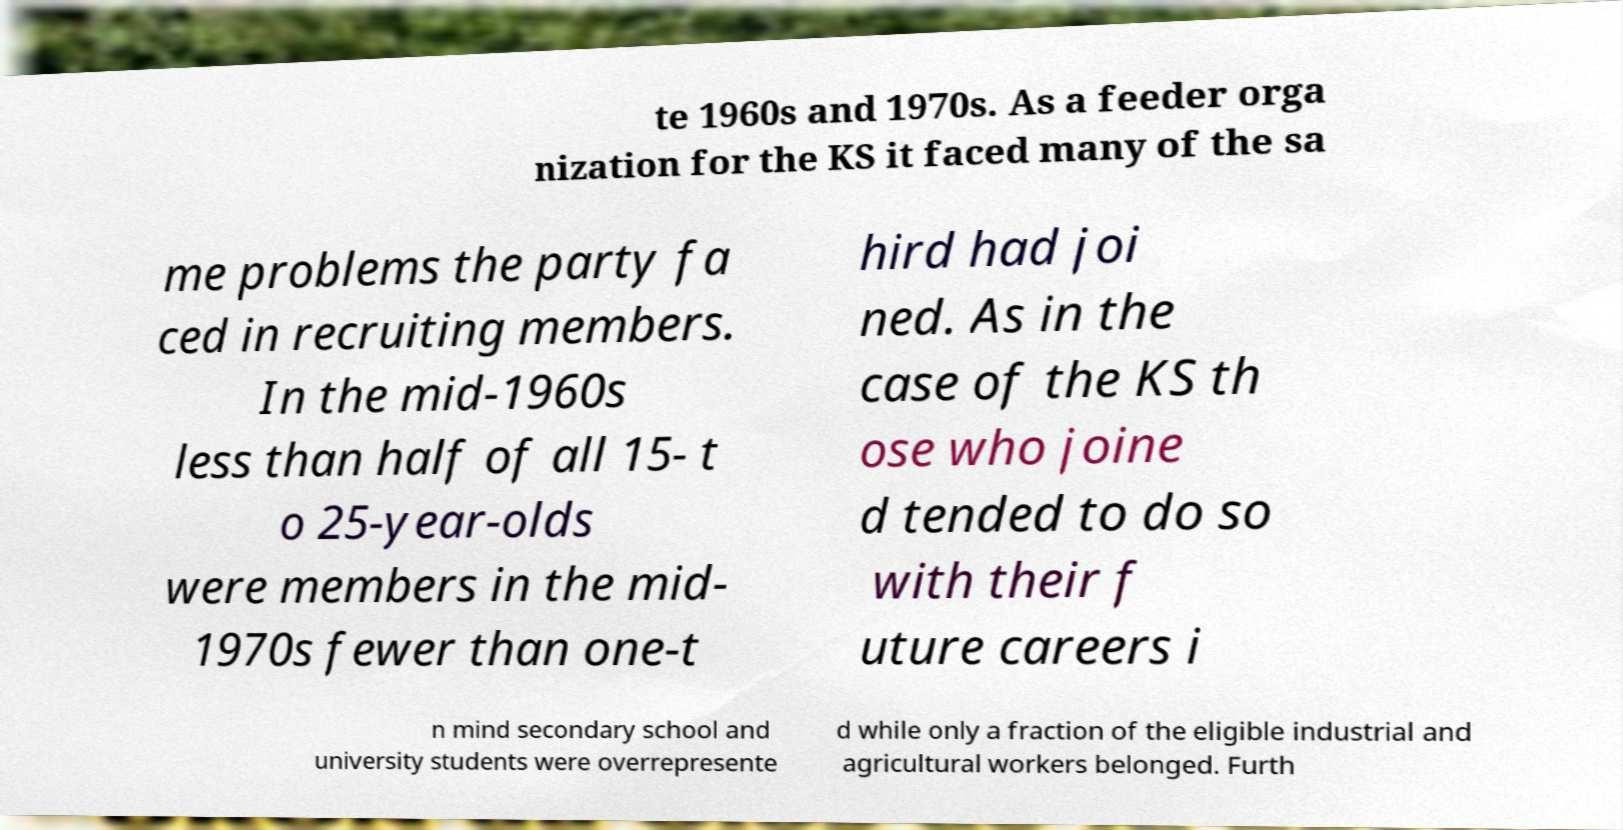I need the written content from this picture converted into text. Can you do that? te 1960s and 1970s. As a feeder orga nization for the KS it faced many of the sa me problems the party fa ced in recruiting members. In the mid-1960s less than half of all 15- t o 25-year-olds were members in the mid- 1970s fewer than one-t hird had joi ned. As in the case of the KS th ose who joine d tended to do so with their f uture careers i n mind secondary school and university students were overrepresente d while only a fraction of the eligible industrial and agricultural workers belonged. Furth 